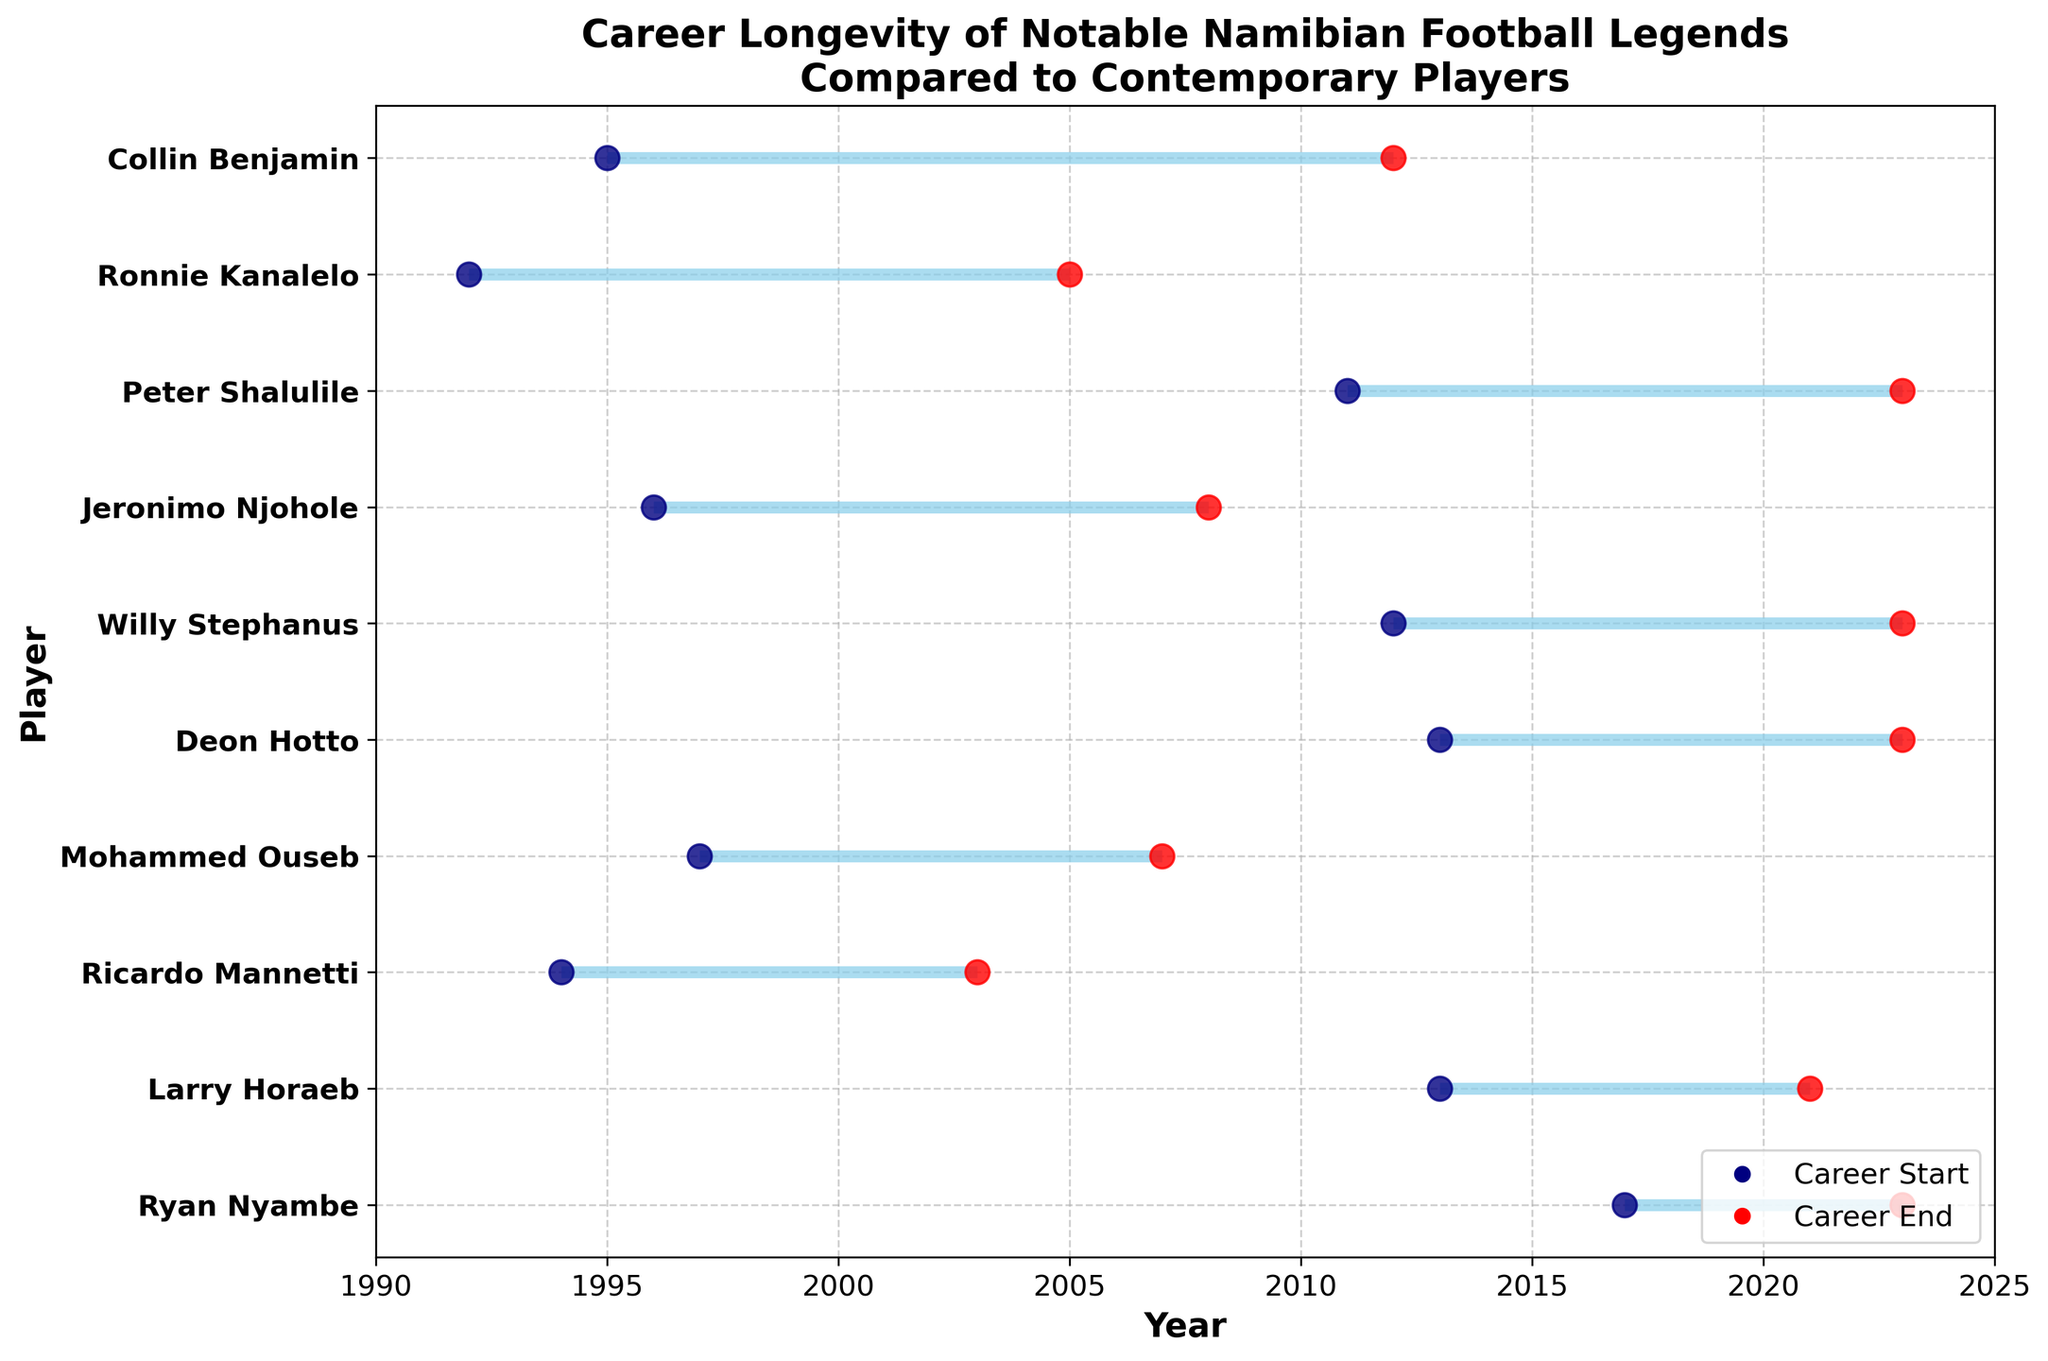What's the title of the plot? The plot's title is displayed at the top of the figure. It is the first thing one would read to understand the context of the visualization.
Answer: Career Longevity of Notable Namibian Football Legends Compared to Contemporary Players What do the blue and red dots represent in the plot? By looking at different parts of the plot, one can see a legend at the bottom right that clarifies what each colored dot means. The blue dots represent when each player's career started, and the red dots show when it ended.
Answer: Blue dots represent career start; red dots represent career end How many players have an ongoing career? The end of the player’s career is marked with a red dot. Players without a red dot have their careers marked as ongoing.
Answer: Four Who has the longest career among the legendary players? To identify the player with the longest career, one needs to calculate the career length for each legendary player. Collin Benjamin's career spans from 1995 to 2012, the longest of all legendary players.
Answer: Collin Benjamin Which contemporary player has the longest career so far? Similar to the legendary players, calculate the career length for each contemporary player and compare. Peter Shalulile has the longest career from 2011 to 2023, which is still ongoing.
Answer: Peter Shalulile Between Ricardo Mannetti and Ronnie Kanalelo, who had a longer career? Calculate the career length for each player. Ricardo Mannetti's career was from 1994 to 2003 (9 years), while Ronnie Kanalelo's career was from 1992 to 2005 (13 years).
Answer: Ronnie Kanalelo Who's had a shorter career, Jeronimo Njohole or Larry Horaeb? Calculate the career length for both players. Jeronimo Njohole's career was from 1996 to 2008 (12 years), and Larry Horaeb's was from 2013 to 2021 (8 years).
Answer: Larry Horaeb What is the average career length of the legendary players? Calculate the total career length of all legendary players and divide by the number of players. (1994-2003)+(1997-2007)+(1995-2012)+(1992-2005)+(1996-2008) = 9+10+17+13+12=61, then 61/5 = 12.2 years.
Answer: 12.2 years What is the average career length of contemporary players (till 2023)? Calculate the career length of each contemporary player who has finished or is still ongoing till 2023 and find the average. (2011-2023)+(2013-2023)+(2012-2023)+(2017-2023)+(2013-2021) = 12+10+11+6+8 = 47, then 47/5 = 9.4 years.
Answer: 9.4 years Are there any players who have careers spanning three different decades? Check each player's career span to see if it crosses three different decades. Collin Benjamin's career spans from 1995 to 2012, covering the 1990s, 2000s, and 2010s.
Answer: Yes, Collin Benjamin 